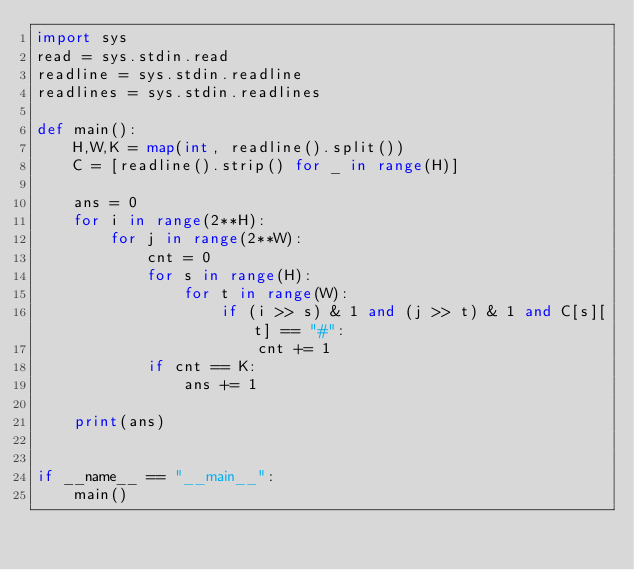Convert code to text. <code><loc_0><loc_0><loc_500><loc_500><_Python_>import sys
read = sys.stdin.read
readline = sys.stdin.readline
readlines = sys.stdin.readlines

def main():
    H,W,K = map(int, readline().split())
    C = [readline().strip() for _ in range(H)]
    
    ans = 0
    for i in range(2**H):
        for j in range(2**W):
            cnt = 0
            for s in range(H):
                for t in range(W):
                    if (i >> s) & 1 and (j >> t) & 1 and C[s][t] == "#":
                        cnt += 1
            if cnt == K:
                ans += 1

    print(ans)


if __name__ == "__main__":
    main()
</code> 